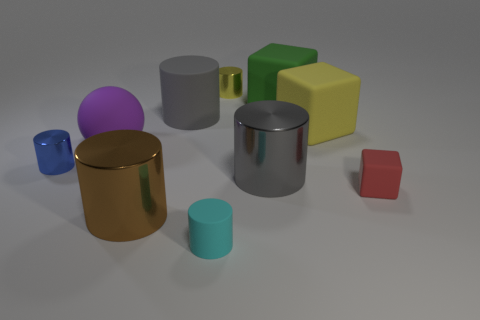There is a rubber cylinder that is behind the big gray shiny thing in front of the purple sphere; are there any large gray cylinders on the right side of it?
Keep it short and to the point. Yes. What shape is the small object that is made of the same material as the red cube?
Provide a short and direct response. Cylinder. Is the number of small yellow shiny cylinders greater than the number of large cyan rubber cylinders?
Offer a very short reply. Yes. Is the shape of the brown metallic thing the same as the metal object behind the large yellow cube?
Offer a terse response. Yes. What is the material of the tiny blue thing?
Make the answer very short. Metal. The large matte cylinder right of the small object on the left side of the large shiny thing in front of the small red thing is what color?
Keep it short and to the point. Gray. There is a tiny blue thing that is the same shape as the small cyan matte object; what material is it?
Your answer should be very brief. Metal. How many other objects have the same size as the green thing?
Your answer should be compact. 5. How many tiny purple metal cylinders are there?
Make the answer very short. 0. Do the small red cube and the large object on the left side of the big brown metal object have the same material?
Your answer should be very brief. Yes. 